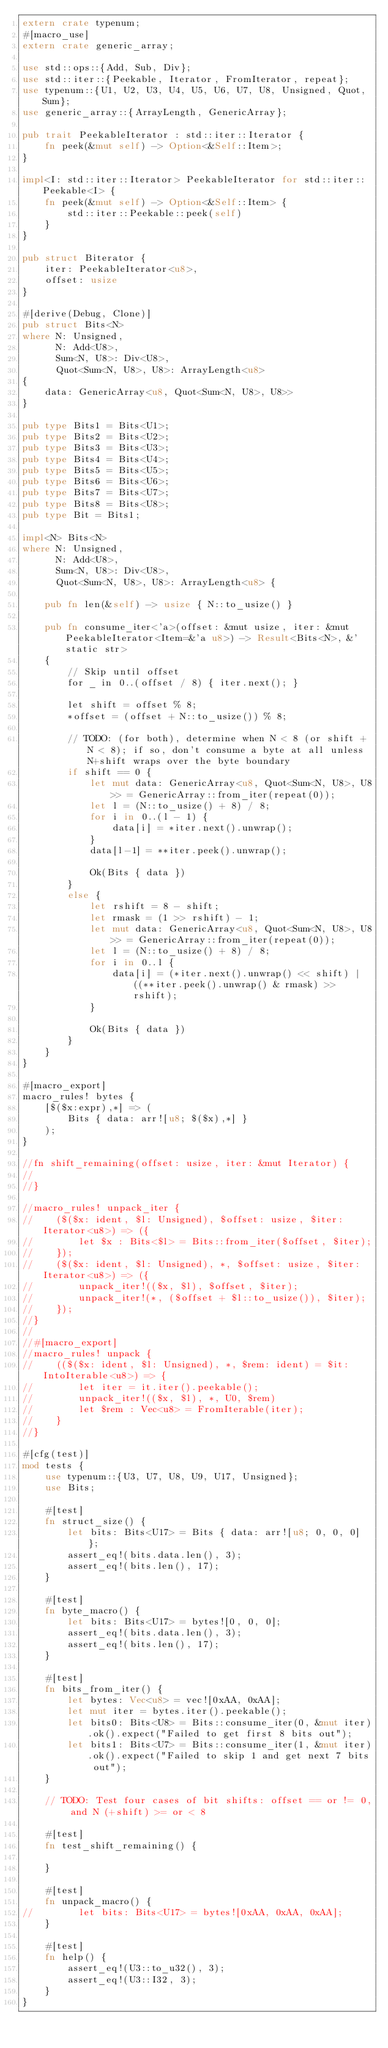Convert code to text. <code><loc_0><loc_0><loc_500><loc_500><_Rust_>extern crate typenum;
#[macro_use]
extern crate generic_array;

use std::ops::{Add, Sub, Div};
use std::iter::{Peekable, Iterator, FromIterator, repeat};
use typenum::{U1, U2, U3, U4, U5, U6, U7, U8, Unsigned, Quot, Sum};
use generic_array::{ArrayLength, GenericArray};

pub trait PeekableIterator : std::iter::Iterator {
    fn peek(&mut self) -> Option<&Self::Item>;
}

impl<I: std::iter::Iterator> PeekableIterator for std::iter::Peekable<I> {
    fn peek(&mut self) -> Option<&Self::Item> {
        std::iter::Peekable::peek(self)
    }
}

pub struct Biterator {
    iter: PeekableIterator<u8>,
    offset: usize
}

#[derive(Debug, Clone)]
pub struct Bits<N>
where N: Unsigned,
      N: Add<U8>,
      Sum<N, U8>: Div<U8>,
      Quot<Sum<N, U8>, U8>: ArrayLength<u8>
{
    data: GenericArray<u8, Quot<Sum<N, U8>, U8>>
}

pub type Bits1 = Bits<U1>;
pub type Bits2 = Bits<U2>;
pub type Bits3 = Bits<U3>;
pub type Bits4 = Bits<U4>;
pub type Bits5 = Bits<U5>;
pub type Bits6 = Bits<U6>;
pub type Bits7 = Bits<U7>;
pub type Bits8 = Bits<U8>;
pub type Bit = Bits1;

impl<N> Bits<N>
where N: Unsigned,
      N: Add<U8>,
      Sum<N, U8>: Div<U8>,
      Quot<Sum<N, U8>, U8>: ArrayLength<u8> {

    pub fn len(&self) -> usize { N::to_usize() }

    pub fn consume_iter<'a>(offset: &mut usize, iter: &mut PeekableIterator<Item=&'a u8>) -> Result<Bits<N>, &'static str>
    {
        // Skip until offset
        for _ in 0..(offset / 8) { iter.next(); }

        let shift = offset % 8;
        *offset = (offset + N::to_usize()) % 8;

        // TODO: (for both), determine when N < 8 (or shift + N < 8); if so, don't consume a byte at all unless N+shift wraps over the byte boundary
        if shift == 0 {
            let mut data: GenericArray<u8, Quot<Sum<N, U8>, U8>> = GenericArray::from_iter(repeat(0));
            let l = (N::to_usize() + 8) / 8;
            for i in 0..(l - 1) {
                data[i] = *iter.next().unwrap();
            }
            data[l-1] = **iter.peek().unwrap();

            Ok(Bits { data })
        }
        else {
            let rshift = 8 - shift;
            let rmask = (1 >> rshift) - 1;
            let mut data: GenericArray<u8, Quot<Sum<N, U8>, U8>> = GenericArray::from_iter(repeat(0));
            let l = (N::to_usize() + 8) / 8;
            for i in 0..l {
                data[i] = (*iter.next().unwrap() << shift) | ((**iter.peek().unwrap() & rmask) >> rshift);
            }

            Ok(Bits { data })
        }
    }
}

#[macro_export]
macro_rules! bytes {
    [$($x:expr),*] => (
        Bits { data: arr![u8; $($x),*] }
    );
}

//fn shift_remaining(offset: usize, iter: &mut Iterator) {
//
//}

//macro_rules! unpack_iter {
//    ($($x: ident, $l: Unsigned), $offset: usize, $iter: Iterator<u8>) => ({
//        let $x : Bits<$l> = Bits::from_iter($offset, $iter);
//    });
//    ($($x: ident, $l: Unsigned), *, $offset: usize, $iter: Iterator<u8>) => ({
//        unpack_iter!(($x, $l), $offset, $iter);
//        unpack_iter!(*, ($offset + $l::to_usize()), $iter);
//    });
//}
//
//#[macro_export]
//macro_rules! unpack {
//    (($($x: ident, $l: Unsigned), *, $rem: ident) = $it: IntoIterable<u8>) => {
//        let iter = it.iter().peekable();
//        unpack_iter!(($x, $l), *, U0, $rem)
//        let $rem : Vec<u8> = FromIterable(iter);
//    }
//}

#[cfg(test)]
mod tests {
    use typenum::{U3, U7, U8, U9, U17, Unsigned};
    use Bits;

    #[test]
    fn struct_size() {
        let bits: Bits<U17> = Bits { data: arr![u8; 0, 0, 0] };
        assert_eq!(bits.data.len(), 3);
        assert_eq!(bits.len(), 17);
    }

    #[test]
    fn byte_macro() {
        let bits: Bits<U17> = bytes![0, 0, 0];
        assert_eq!(bits.data.len(), 3);
        assert_eq!(bits.len(), 17);
    }

    #[test]
    fn bits_from_iter() {
        let bytes: Vec<u8> = vec![0xAA, 0xAA];
        let mut iter = bytes.iter().peekable();
        let bits0: Bits<U8> = Bits::consume_iter(0, &mut iter).ok().expect("Failed to get first 8 bits out");
        let bits1: Bits<U7> = Bits::consume_iter(1, &mut iter).ok().expect("Failed to skip 1 and get next 7 bits out");
    }

    // TODO: Test four cases of bit shifts: offset == or != 0, and N (+shift) >= or < 8

    #[test]
    fn test_shift_remaining() {

    }

    #[test]
    fn unpack_macro() {
//        let bits: Bits<U17> = bytes![0xAA, 0xAA, 0xAA];
    }

    #[test]
    fn help() {
        assert_eq!(U3::to_u32(), 3);
        assert_eq!(U3::I32, 3);
    }
}
</code> 